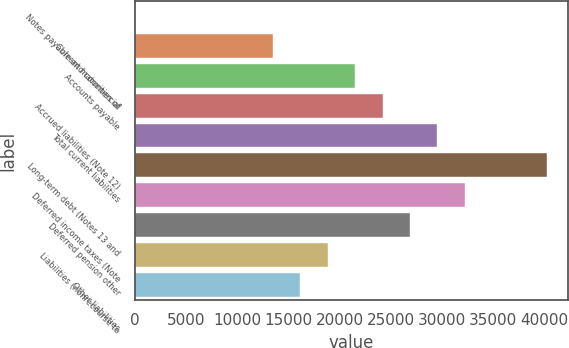<chart> <loc_0><loc_0><loc_500><loc_500><bar_chart><fcel>Notes payable and commercial<fcel>Current maturities of<fcel>Accounts payable<fcel>Accrued liabilities (Note 12)<fcel>Total current liabilities<fcel>Long-term debt (Notes 13 and<fcel>Deferred income taxes (Note<fcel>Deferred pension other<fcel>Liabilities (nonrecourse to<fcel>Other liabilities<nl><fcel>72<fcel>13467<fcel>21504<fcel>24183<fcel>29541<fcel>40257<fcel>32220<fcel>26862<fcel>18825<fcel>16146<nl></chart> 